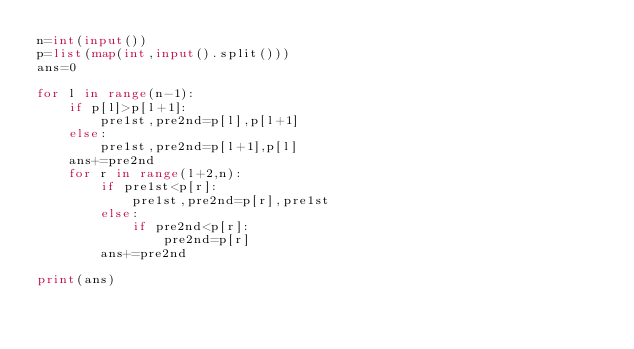<code> <loc_0><loc_0><loc_500><loc_500><_Python_>n=int(input())
p=list(map(int,input().split()))
ans=0

for l in range(n-1):
    if p[l]>p[l+1]:
        pre1st,pre2nd=p[l],p[l+1]
    else:
        pre1st,pre2nd=p[l+1],p[l]
    ans+=pre2nd
    for r in range(l+2,n):
        if pre1st<p[r]:
            pre1st,pre2nd=p[r],pre1st
        else:
            if pre2nd<p[r]:
                pre2nd=p[r]
        ans+=pre2nd

print(ans)</code> 